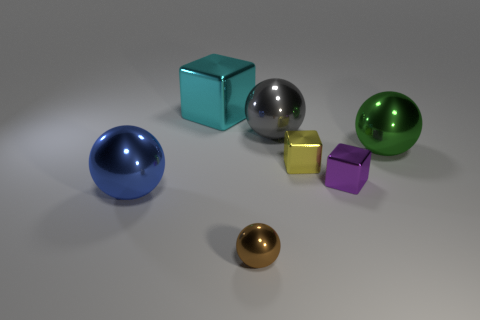Subtract 1 spheres. How many spheres are left? 3 Add 2 large cyan shiny things. How many objects exist? 9 Subtract all blocks. How many objects are left? 4 Add 6 metal balls. How many metal balls are left? 10 Add 3 blue cylinders. How many blue cylinders exist? 3 Subtract 1 blue spheres. How many objects are left? 6 Subtract all big green cylinders. Subtract all big gray spheres. How many objects are left? 6 